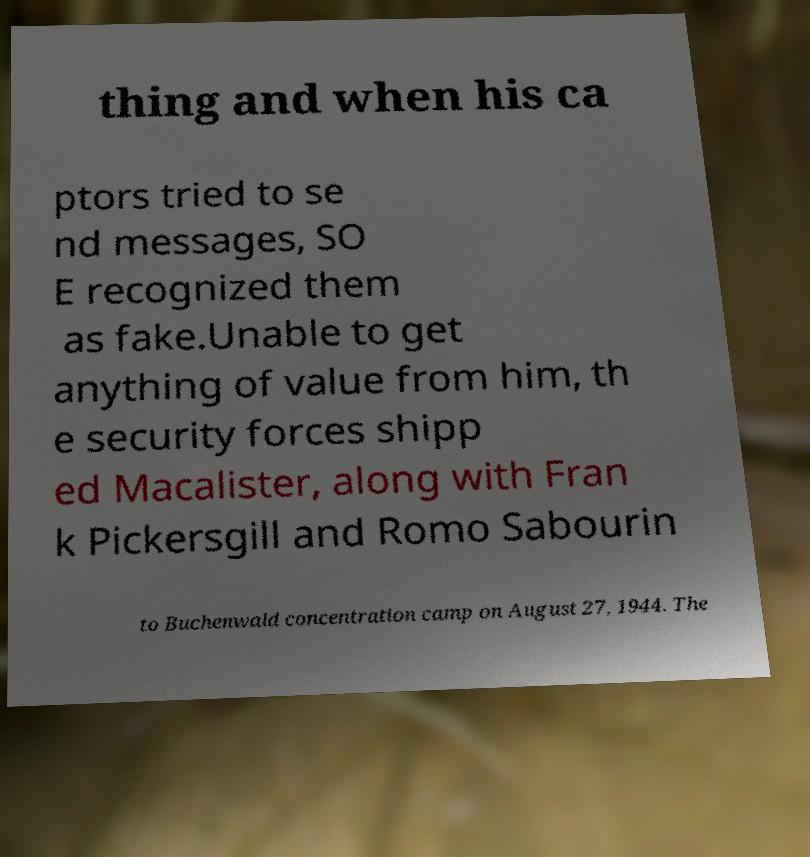Can you read and provide the text displayed in the image?This photo seems to have some interesting text. Can you extract and type it out for me? thing and when his ca ptors tried to se nd messages, SO E recognized them as fake.Unable to get anything of value from him, th e security forces shipp ed Macalister, along with Fran k Pickersgill and Romo Sabourin to Buchenwald concentration camp on August 27, 1944. The 